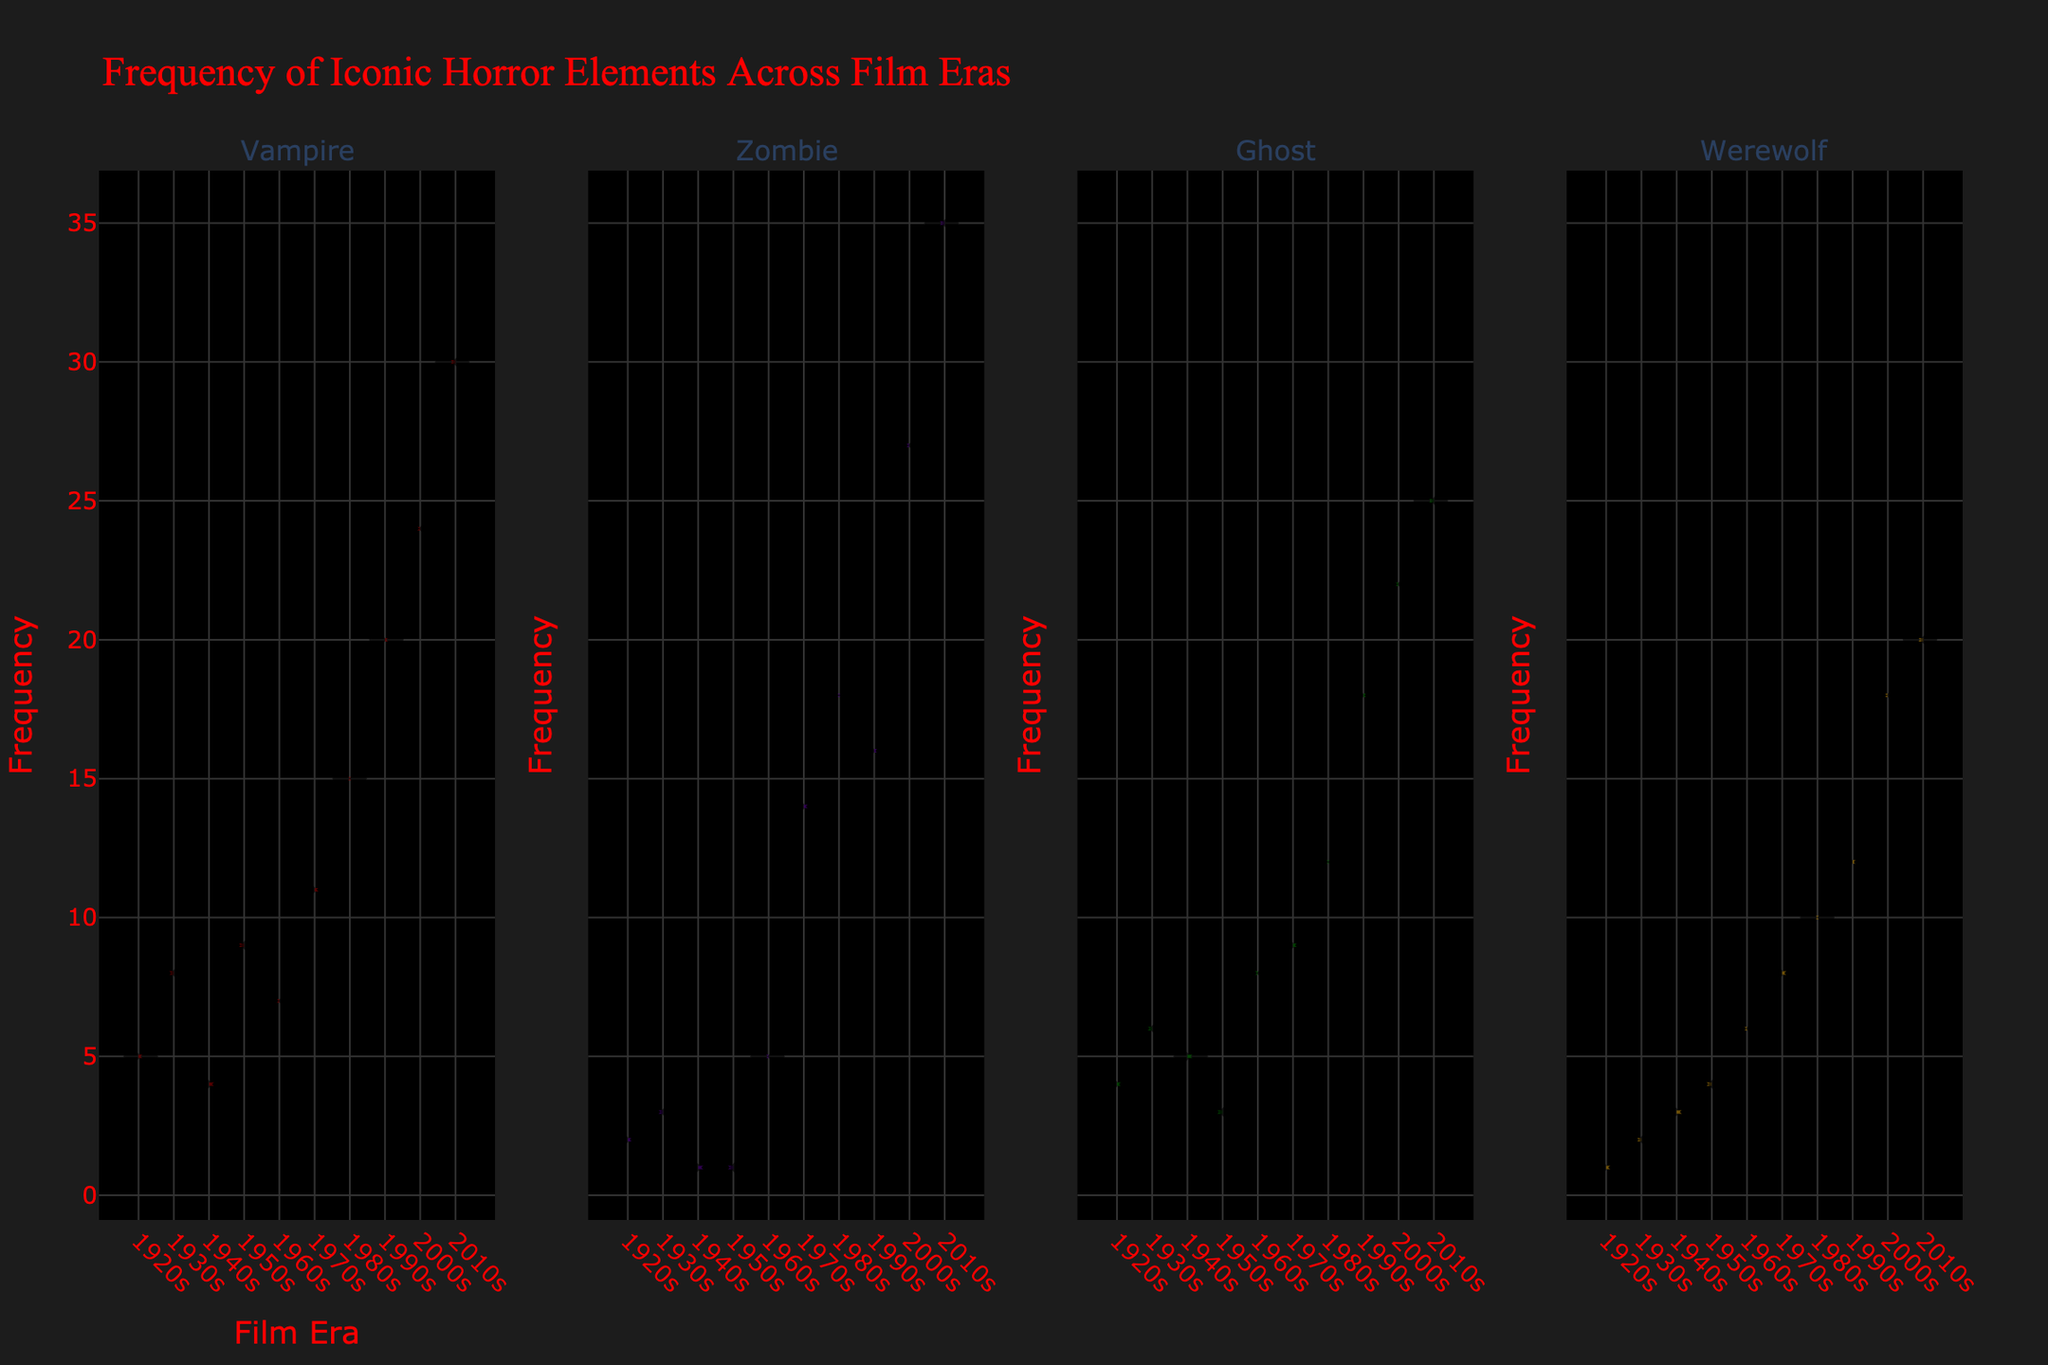What is the title of the figure? The title of the figure is usually located at the top of the chart and provides a summary of what the figure represents.
Answer: Frequency of Iconic Horror Elements Across Film Eras Which element had the highest frequency in the 2010s? To determine the element with the highest frequency in the 2010s, look at the right side of the violin plots for each element under the 2010s era and compare their counts.
Answer: Zombie How did the frequency of Vampires change from the 1920s to the 2010s? Analyze the height of the frequency points for Vampires in the 1920s and compare it with the 2010s. Vampires increased from a count of 5 in the 1920s to 30 in the 2010s.
Answer: Increased Which era saw the highest frequencies for all horror elements combined? Sum the frequencies of Vampires, Zombies, Ghosts, and Werewolves for each era and compare the totals. The 2010s era has the highest combined frequencies (30 + 35 + 25 + 20 = 110).
Answer: 2010s What is the trend of the frequency of Werewolves from the 1940s to the 2010s? Examine the violin plots for Werewolves from the 1940s to the 2010s, focusing on the changes in frequency. Werewolves increased from 3 in the 1940s to 20 in the 2010s.
Answer: Increasing How does the frequency of Vampires in the 1970s compare to that of Zombies in the same era? Look at the violin plots for the 1970s and compare the heights of the data points for Vampires (11) and Zombies (14).
Answer: Vampires are less frequent than Zombies Which film era had the least variation in the frequency of Ghosts? To identify the era with the least variation, observe the distribution width of the violin plots for Ghosts across all eras. The 1940s show the least variation with more concentrated data points.
Answer: 1940s Did any element consistently increase in frequency across all film eras? Review the trends for each element from the 1920s to the 2010s. All elements (Vampires, Zombies, Ghosts, and Werewolves) show consistent increases in frequency.
Answer: Yes Which element had the least frequency increase over time? Compare the initial and final counts for each element from the 1920s to the 2010s, and calculate the differences. Ghosts increased by 21 (25 - 4), Vampires by 25 (30 - 5), Zombies by 33 (35 - 2), and Werewolves by 19 (20 - 1).
Answer: Werewolf What are the colors used for each horror element in the figure? Examine the figure legend or the color of the violin plots; Vampires are dark red, Zombies are indigo/violet, Ghosts are dark green, and Werewolves are golden brown.
Answer: Dark red for Vampires, indigo/violet for Zombies, dark green for Ghosts, golden brown for Werewolves 